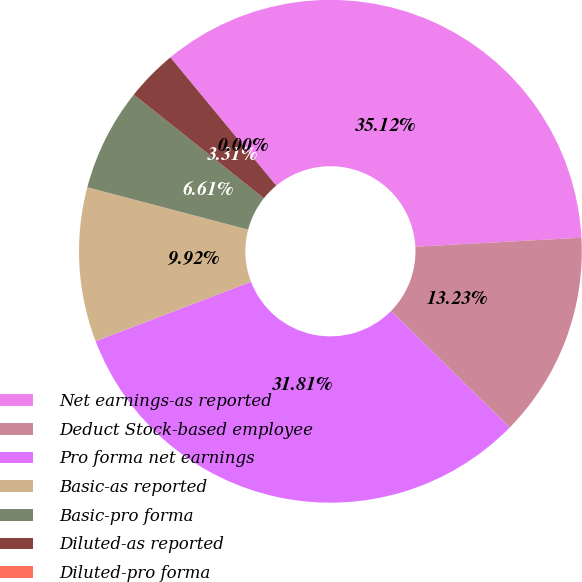Convert chart to OTSL. <chart><loc_0><loc_0><loc_500><loc_500><pie_chart><fcel>Net earnings-as reported<fcel>Deduct Stock-based employee<fcel>Pro forma net earnings<fcel>Basic-as reported<fcel>Basic-pro forma<fcel>Diluted-as reported<fcel>Diluted-pro forma<nl><fcel>35.12%<fcel>13.23%<fcel>31.81%<fcel>9.92%<fcel>6.61%<fcel>3.31%<fcel>0.0%<nl></chart> 